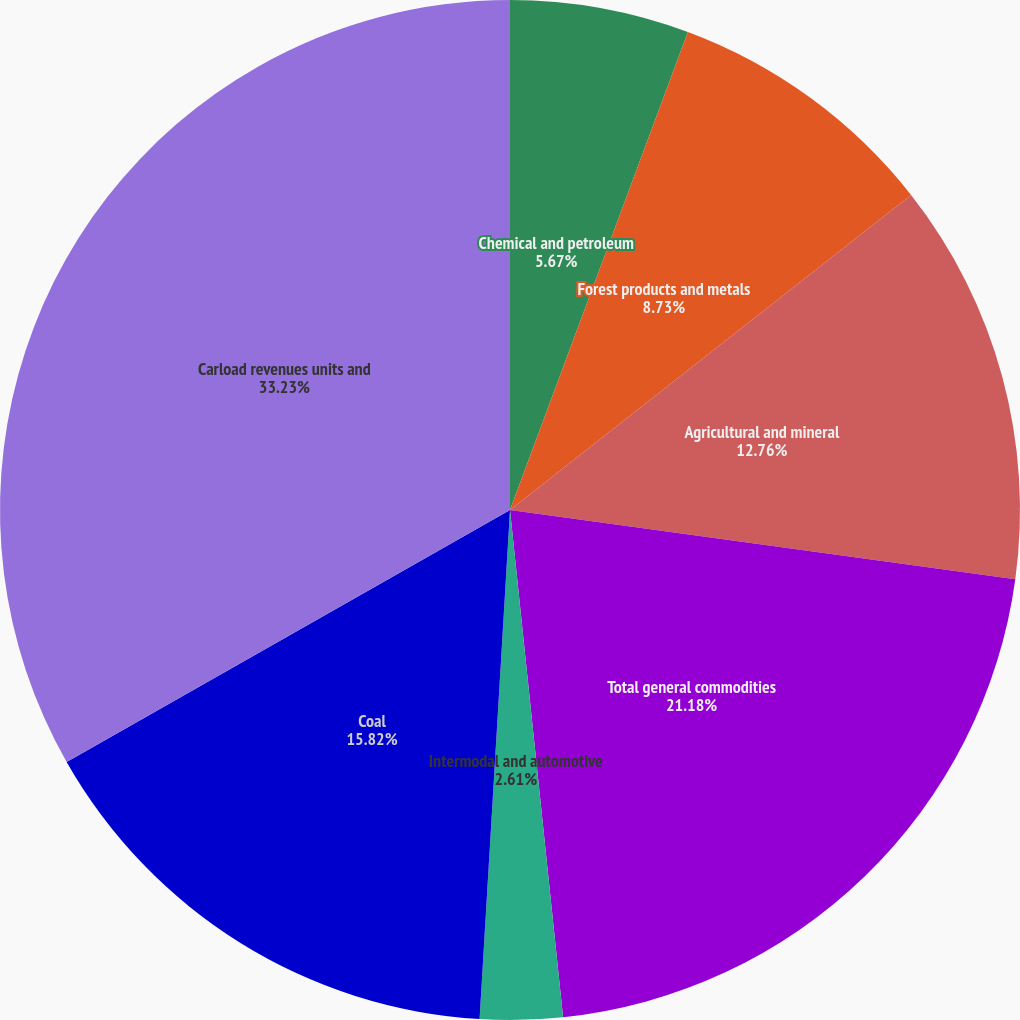<chart> <loc_0><loc_0><loc_500><loc_500><pie_chart><fcel>Chemical and petroleum<fcel>Forest products and metals<fcel>Agricultural and mineral<fcel>Total general commodities<fcel>Intermodal and automotive<fcel>Coal<fcel>Carload revenues units and<nl><fcel>5.67%<fcel>8.73%<fcel>12.76%<fcel>21.17%<fcel>2.61%<fcel>15.82%<fcel>33.22%<nl></chart> 